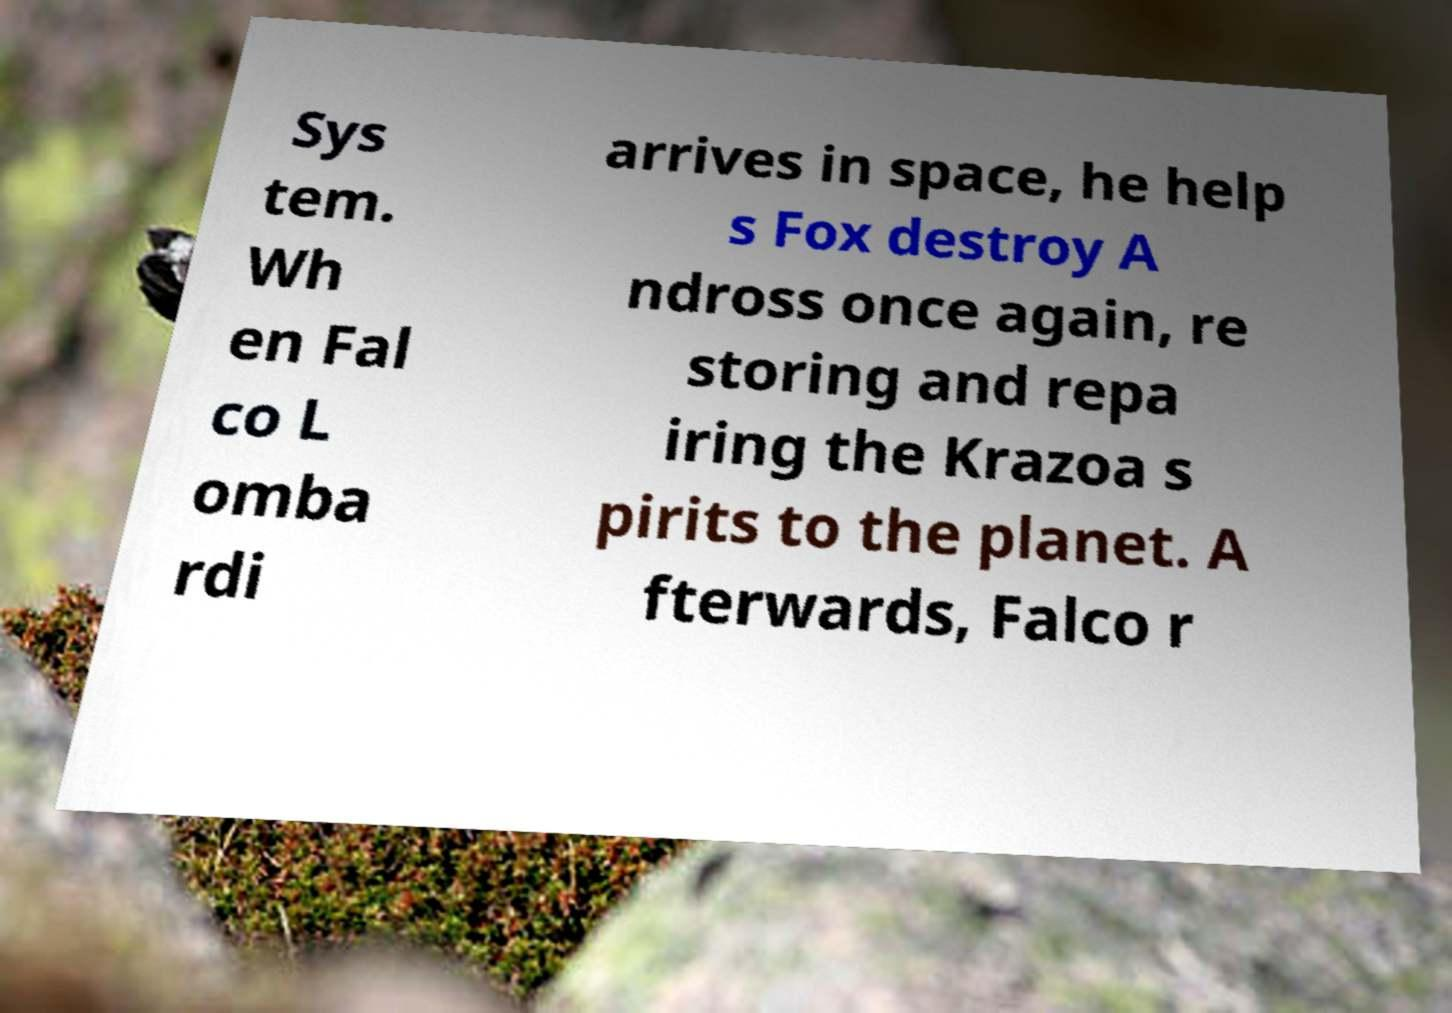Could you extract and type out the text from this image? Sys tem. Wh en Fal co L omba rdi arrives in space, he help s Fox destroy A ndross once again, re storing and repa iring the Krazoa s pirits to the planet. A fterwards, Falco r 